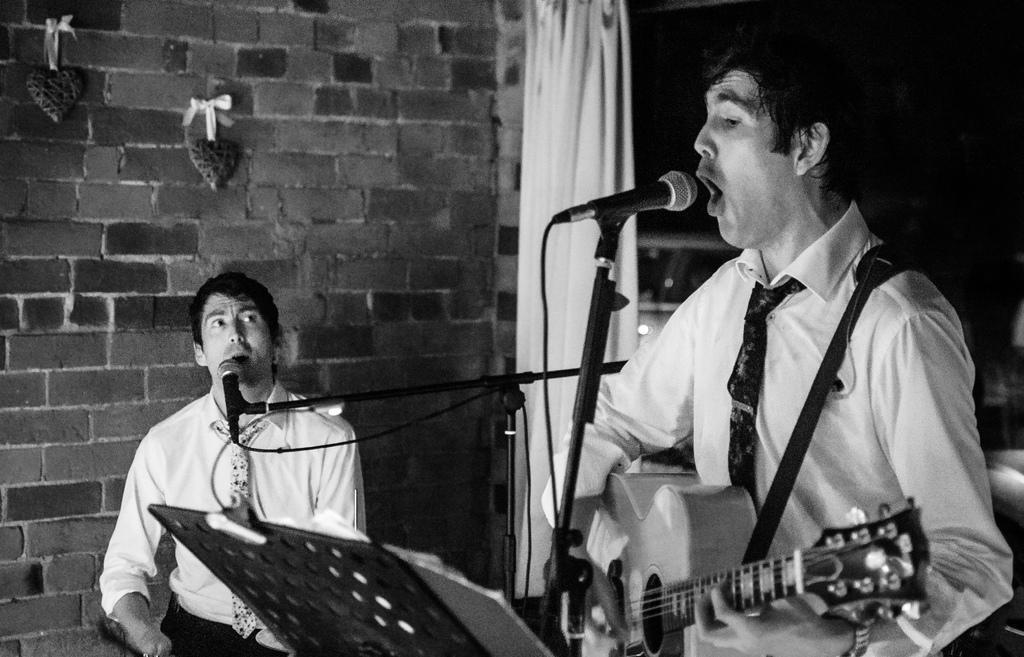Can you describe this image briefly? In the given image we can see two person, this is a microphone. This person is holding a guitar in his hand and he is wearing a white shirt with a tie. 